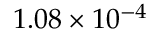<formula> <loc_0><loc_0><loc_500><loc_500>1 . 0 8 \times 1 0 ^ { - 4 }</formula> 